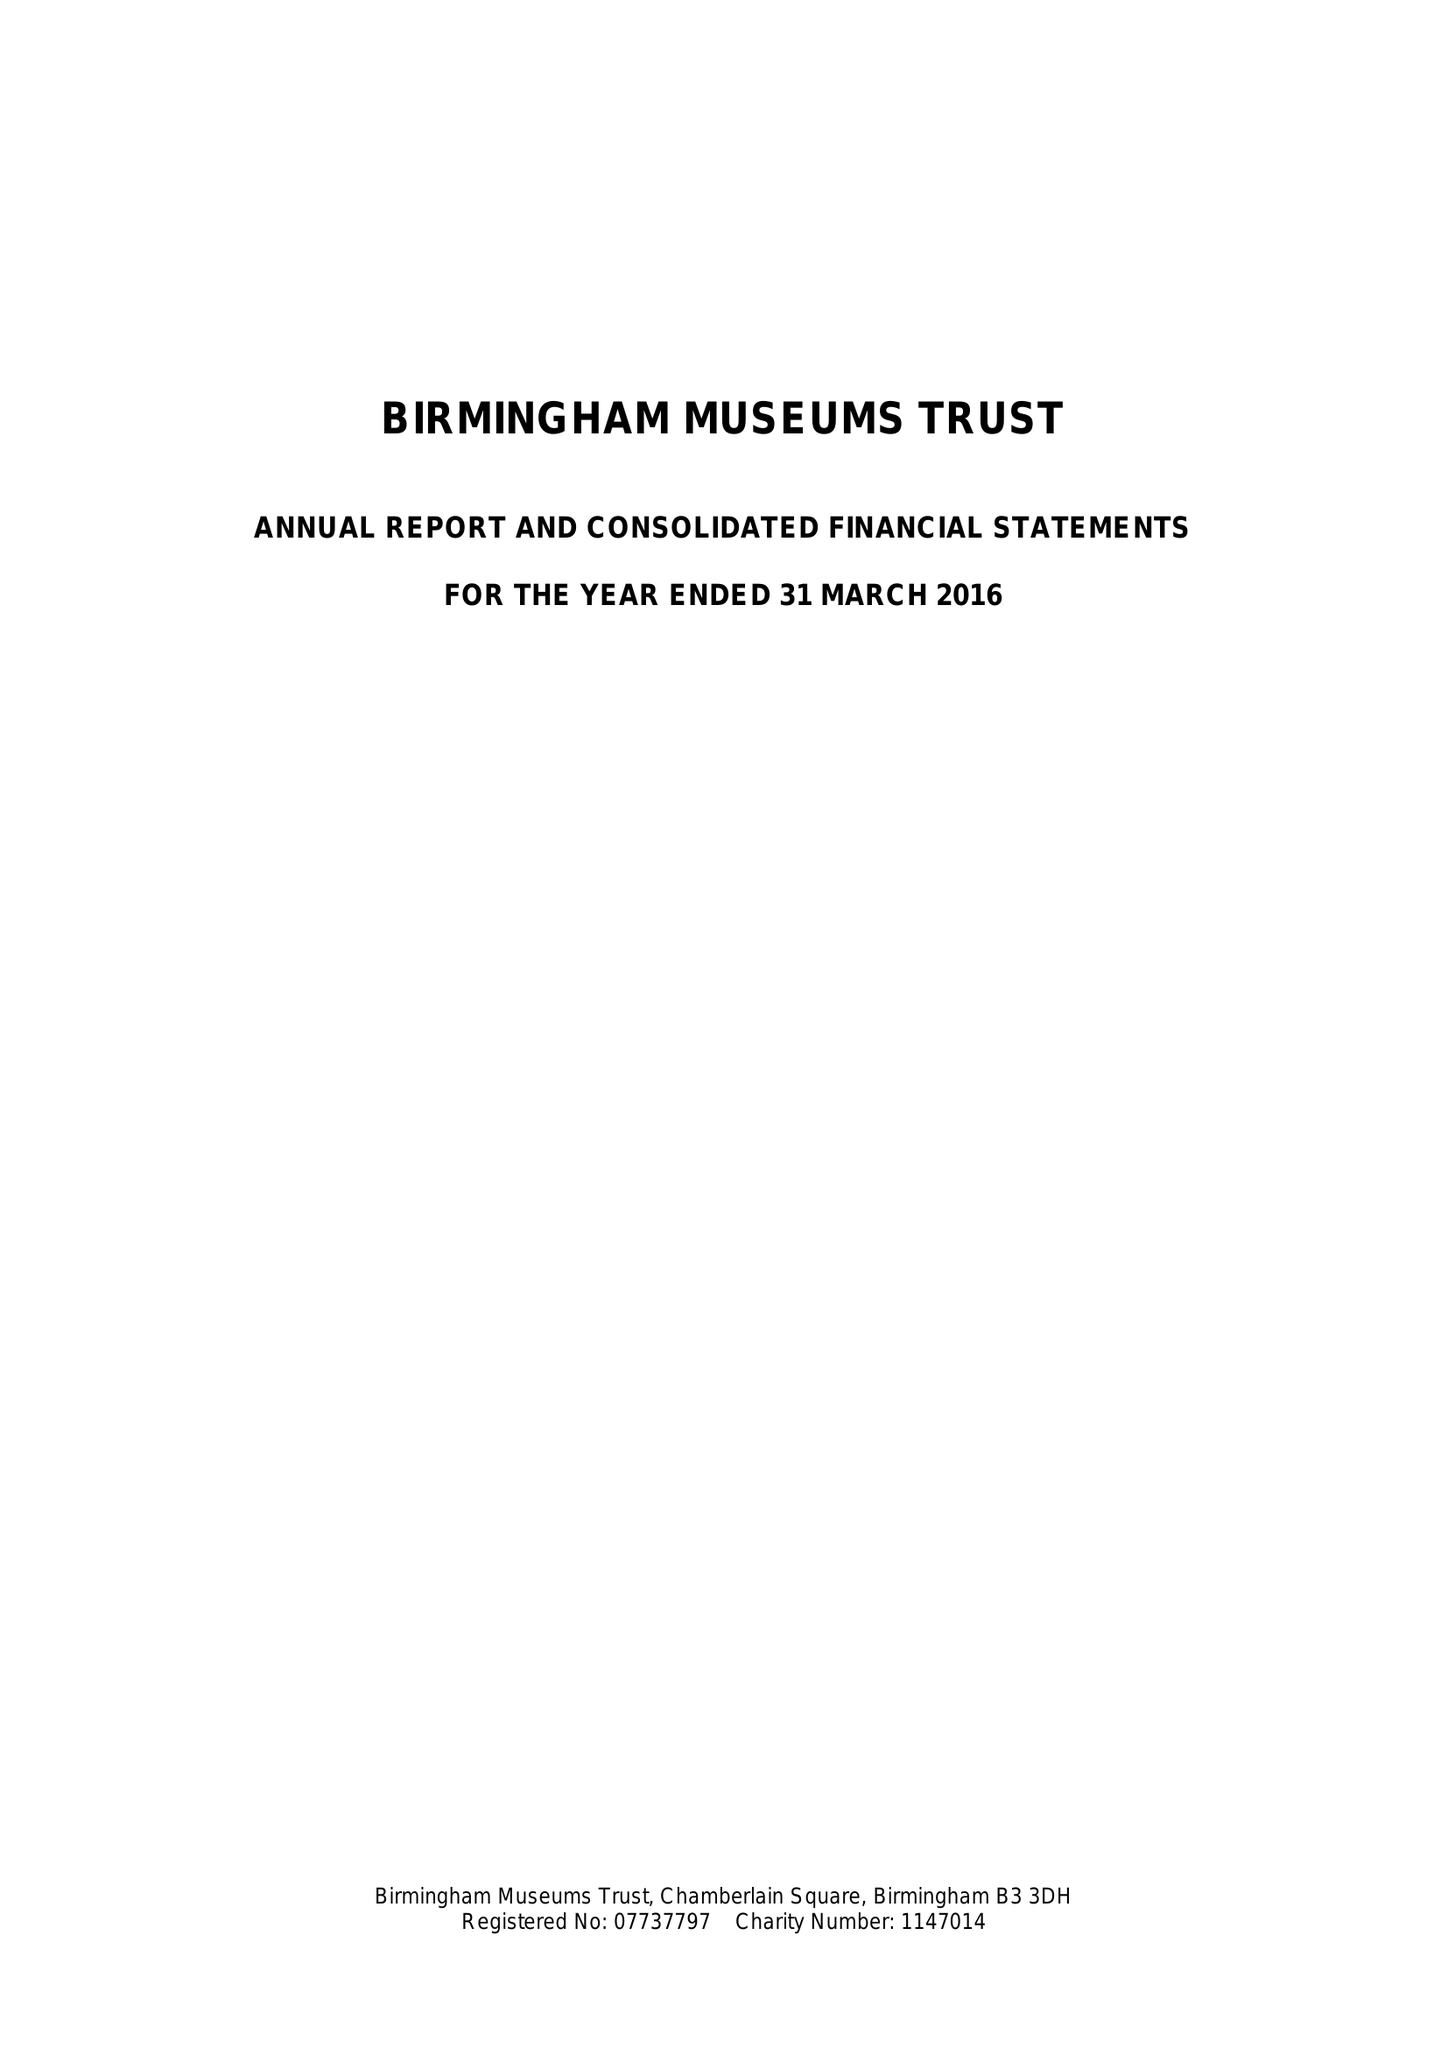What is the value for the charity_name?
Answer the question using a single word or phrase. Birmingham Museums Trust 